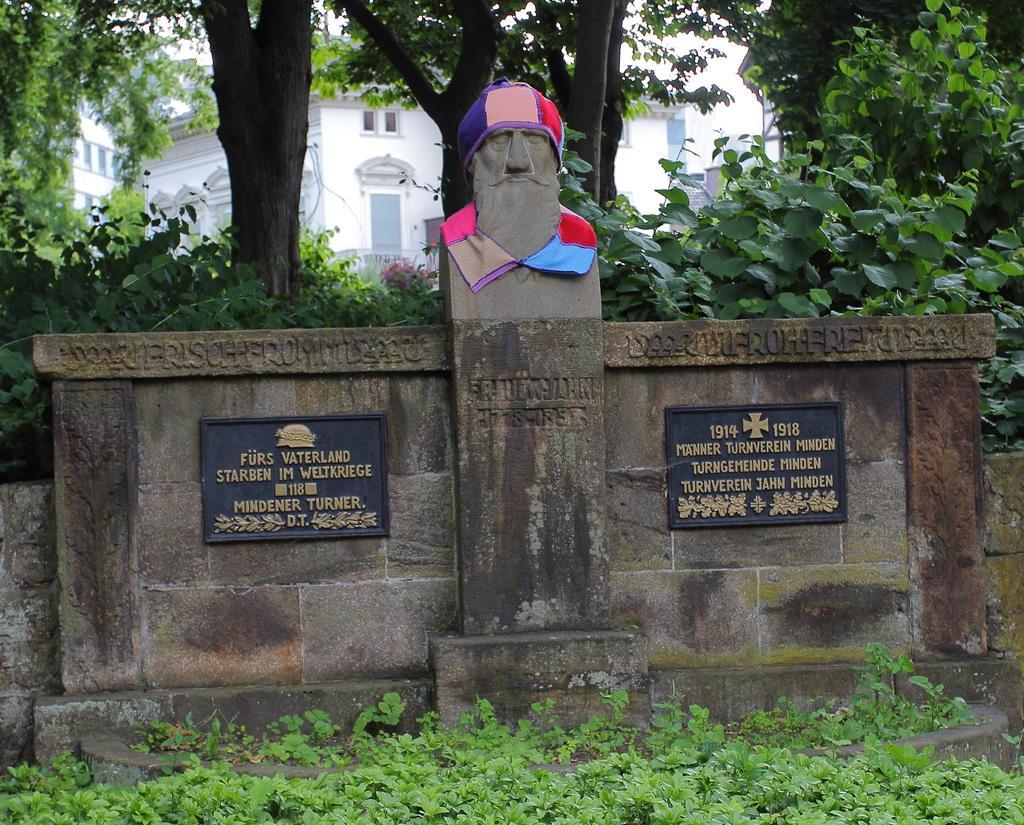Describe this image in one or two sentences. In the image in the center there is a stone, sculpture and banners. In the bottom of the image, we can see the grass. In the background we can see buildings, trees and plants. 